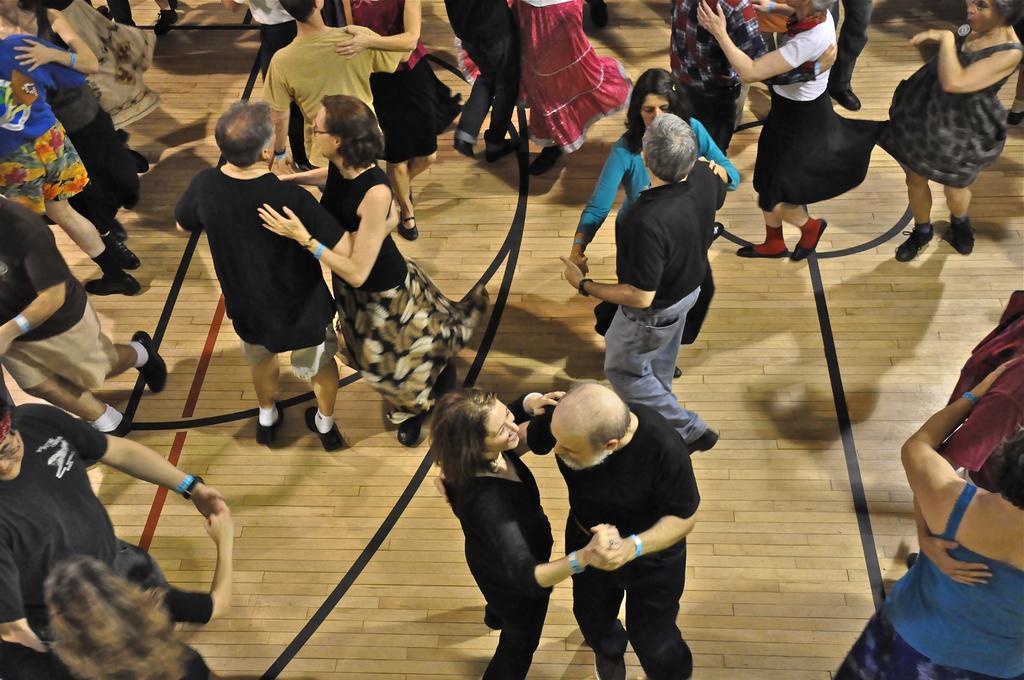In one or two sentences, can you explain what this image depicts? In this image we can see persons dancing on the floor. 